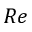<formula> <loc_0><loc_0><loc_500><loc_500>R e</formula> 